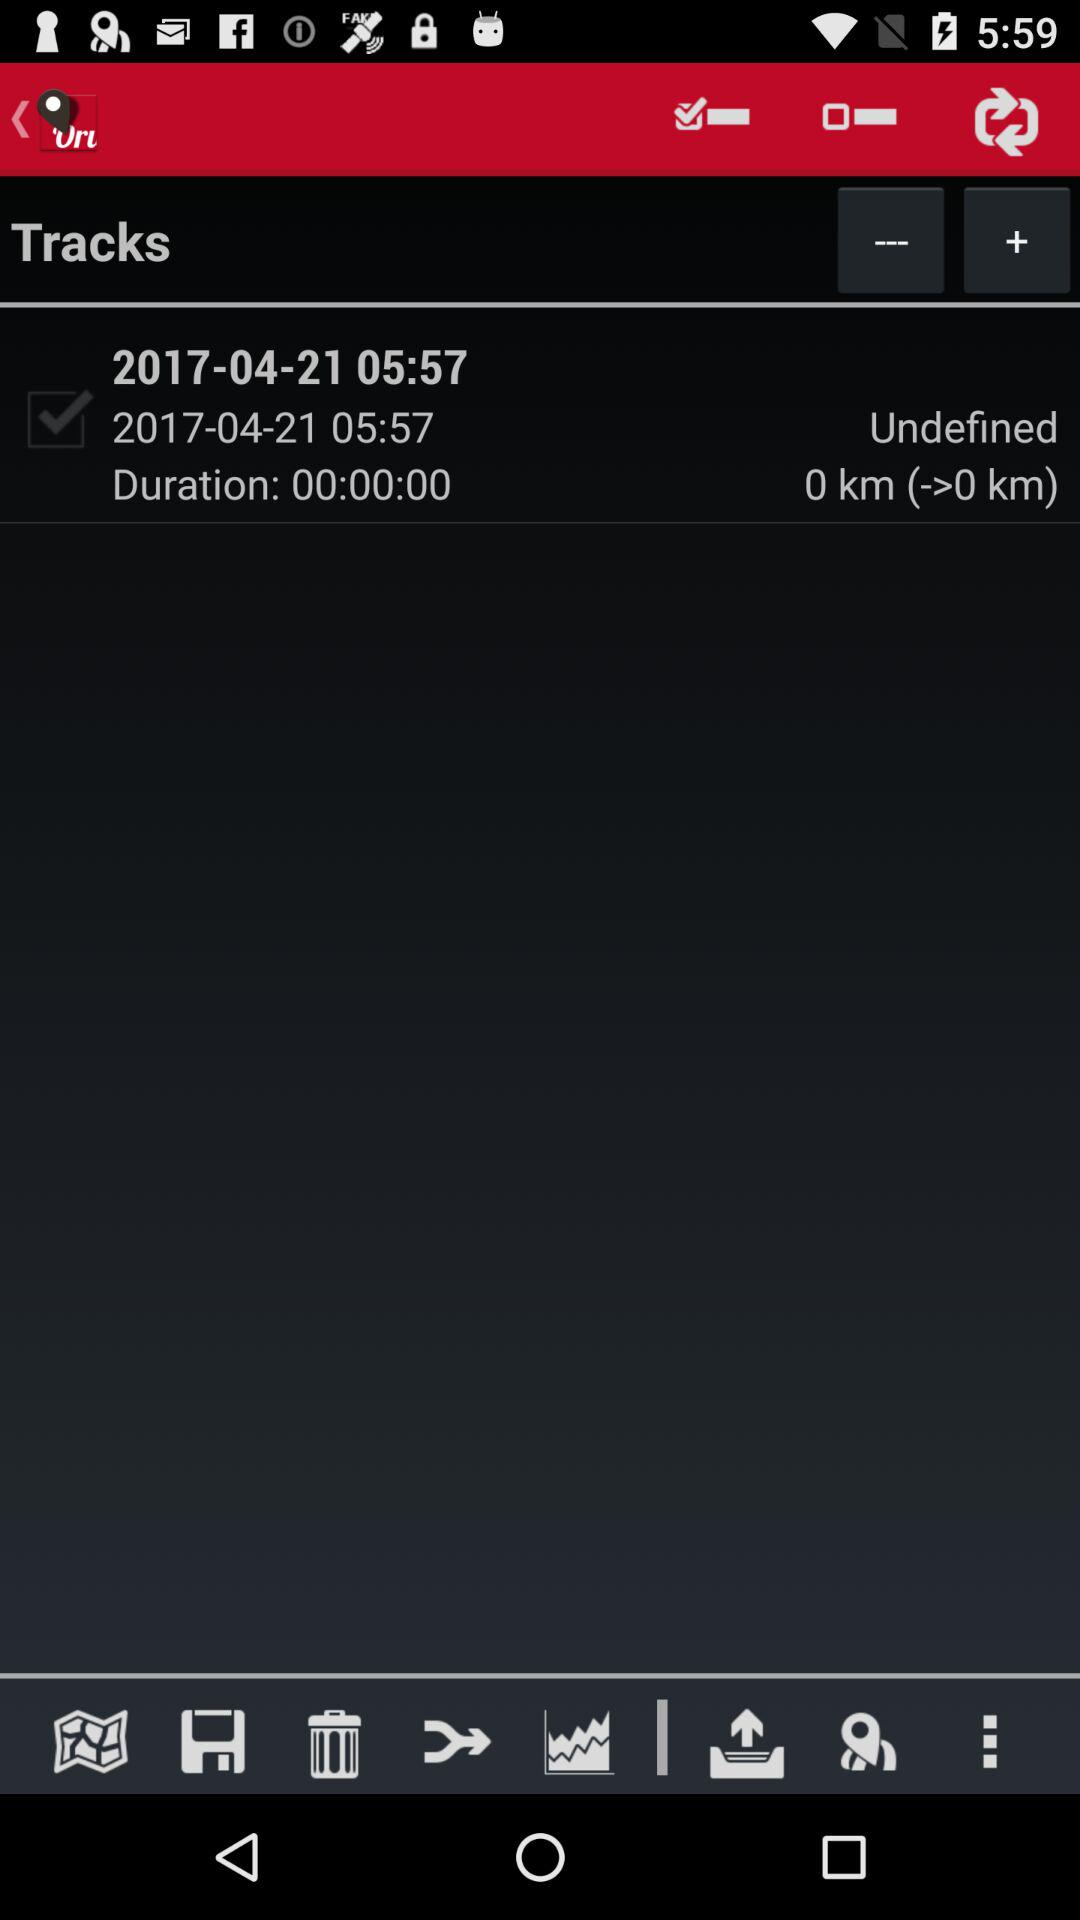What is the location of the track?
Answer the question using a single word or phrase. Undefined 